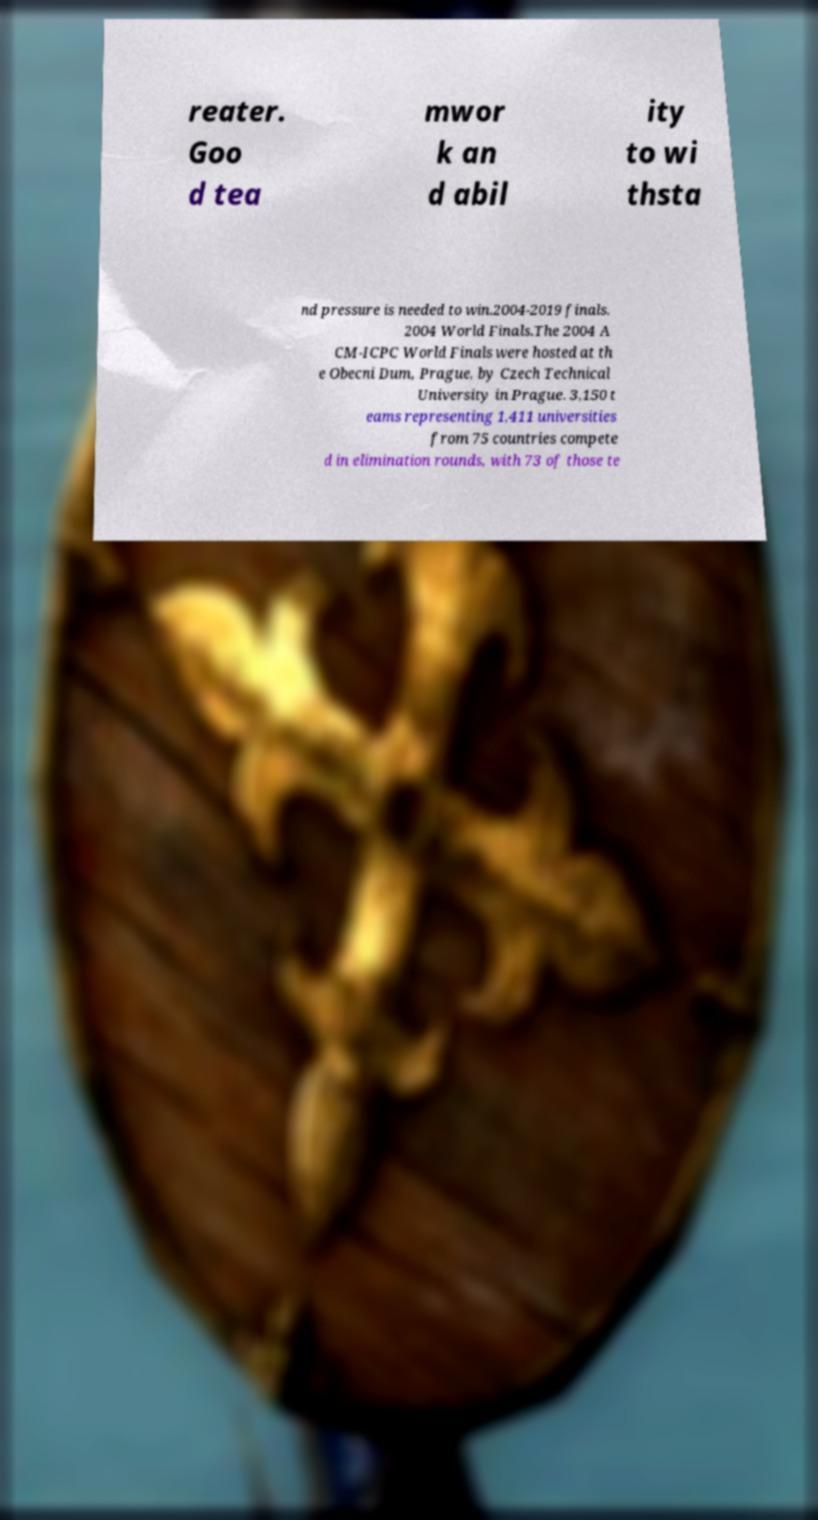What messages or text are displayed in this image? I need them in a readable, typed format. reater. Goo d tea mwor k an d abil ity to wi thsta nd pressure is needed to win.2004-2019 finals. 2004 World Finals.The 2004 A CM-ICPC World Finals were hosted at th e Obecni Dum, Prague, by Czech Technical University in Prague. 3,150 t eams representing 1,411 universities from 75 countries compete d in elimination rounds, with 73 of those te 